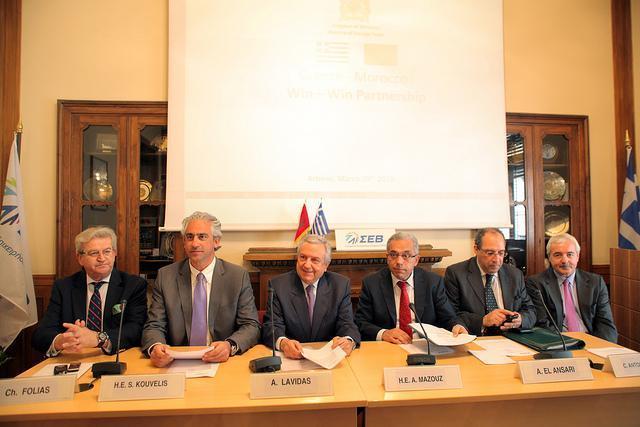How many men are wearing pink ties?
Give a very brief answer. 1. How many people are in the photo?
Give a very brief answer. 6. How many benches are there?
Give a very brief answer. 0. 